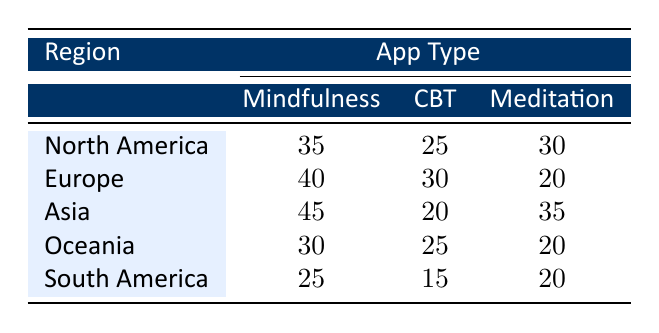What is the frequency of use of Mindfulness apps in North America? The table shows that the frequency of use of Mindfulness apps in North America is listed directly under the corresponding region and app type, which is 35.
Answer: 35 Which region has the highest frequency of use for Cognitive Behavioral Therapy (CBT) apps? By examining the values in the CBT column, Asia has the lowest frequency of 20 and South America has the lowest frequency of 15. The highest frequency is found in Europe with a value of 30.
Answer: Europe What is the combined frequency of use for Meditation apps across all regions? To find the total frequency of Meditation apps, we add the values together: 30 (North America) + 20 (Europe) + 35 (Asia) + 20 (Oceania) + 20 (South America) = 125.
Answer: 125 Is the frequency of use of Meditation apps in Europe higher than in South America? The frequency of Meditation apps in Europe is 20, while in South America it is also 20. Therefore, they are equal, making this statement false.
Answer: No Which region has the lowest total frequency of use across all app types? By adding the frequencies for each region: North America (35 + 25 + 30 = 90), Europe (40 + 30 + 20 = 90), Asia (45 + 20 + 35 = 100), Oceania (30 + 25 + 20 = 75), and South America (25 + 15 + 20 = 60). The lowest total is South America with 60.
Answer: South America What is the average frequency of use for Mindfulness apps across all regions? First, we identify the Mindfulness app frequencies: 35 (North America), 40 (Europe), 45 (Asia), 30 (Oceania), and 25 (South America). Summing these gives 35 + 40 + 45 + 30 + 25 = 175. There are 5 entries, so the average is 175 / 5 = 35.
Answer: 35 In which region is the frequency of Cognitive Behavioral Therapy (CBT) the same as that of Meditation? The frequency of CBT apps are 25 (North America), 30 (Europe), 20 (Asia), 25 (Oceania), and 15 (South America) compared to Meditation frequencies of 30 (North America), 20 (Europe), 35 (Asia), 20 (Oceania), and 20 (South America). There are no regions where the frequencies match; hence, the answer is no.
Answer: No What is the difference in frequency of use between Mindfulness apps in Asia and Oceania? The frequency of Mindfulness apps in Asia is 45, and in Oceania, it is 30. The difference is calculated as 45 - 30 = 15.
Answer: 15 Is the frequency of use for Meditation apps equal in Oceania and South America? The frequency of Meditation apps in Oceania is 20, and in South America, it is also 20. Therefore, they are equal, making this statement true.
Answer: Yes 